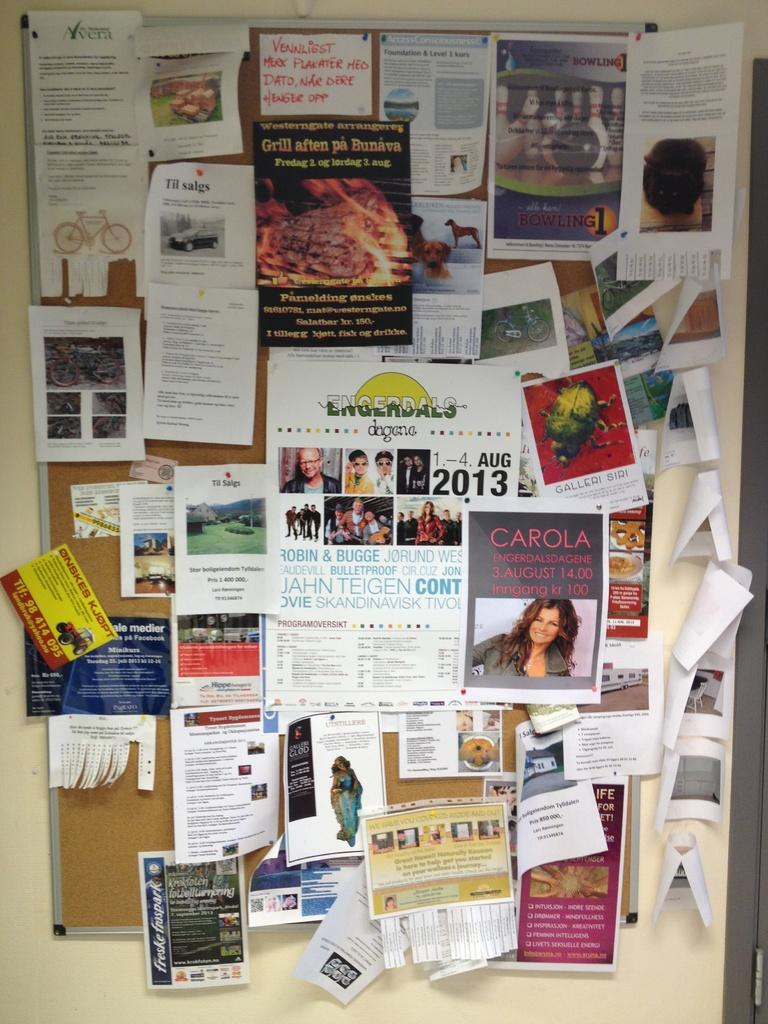<image>
Share a concise interpretation of the image provided. A poster for an August, 2013 event is at the center of a crowded bulletin board. 